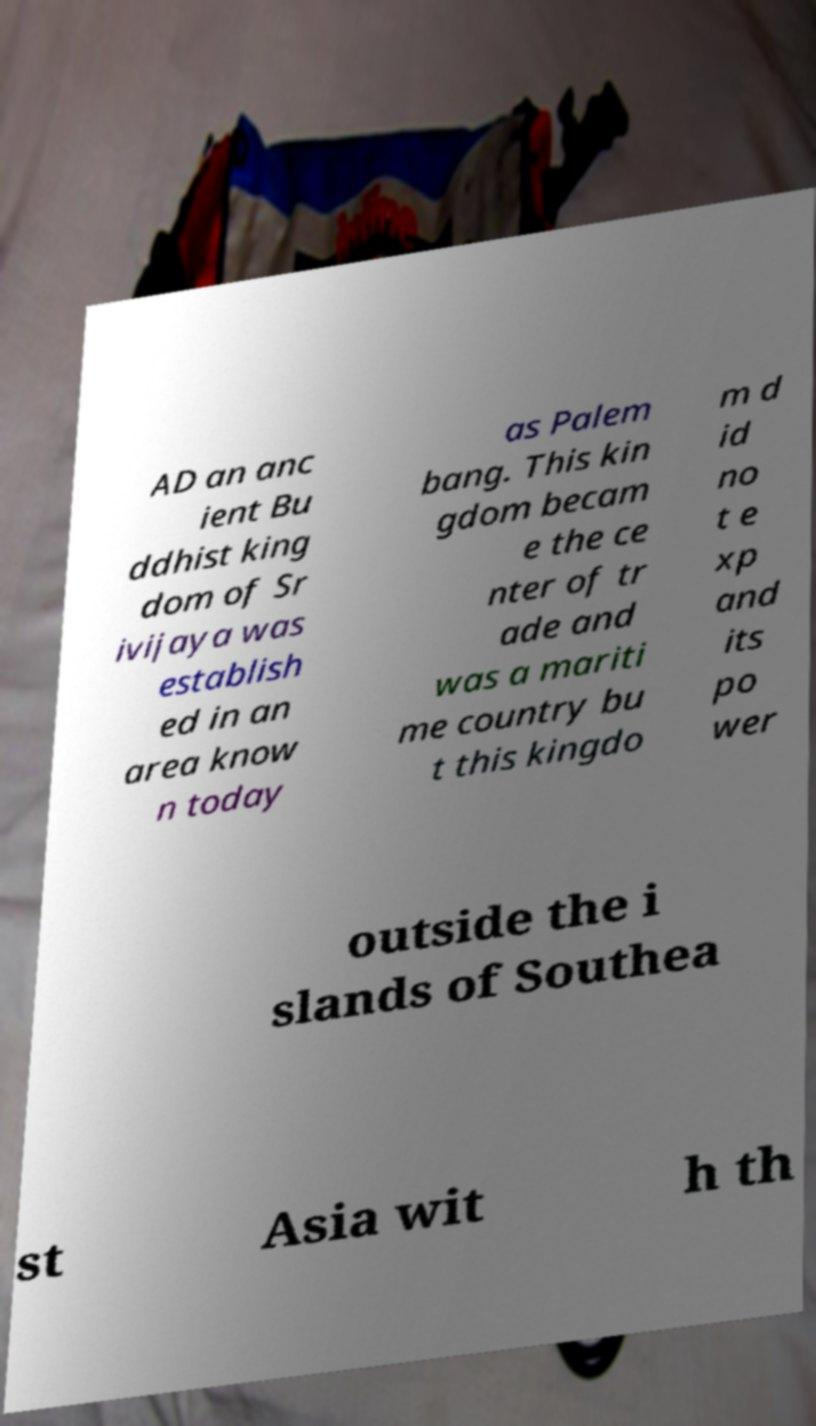I need the written content from this picture converted into text. Can you do that? AD an anc ient Bu ddhist king dom of Sr ivijaya was establish ed in an area know n today as Palem bang. This kin gdom becam e the ce nter of tr ade and was a mariti me country bu t this kingdo m d id no t e xp and its po wer outside the i slands of Southea st Asia wit h th 